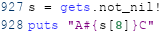Convert code to text. <code><loc_0><loc_0><loc_500><loc_500><_Crystal_>s = gets.not_nil!
puts "A#{s[8]}C"
</code> 